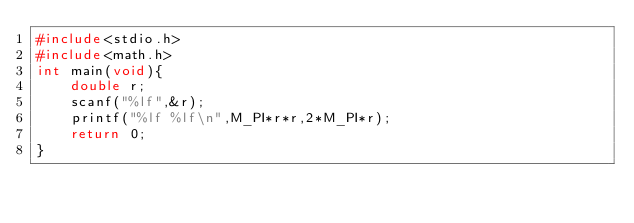<code> <loc_0><loc_0><loc_500><loc_500><_C_>#include<stdio.h>
#include<math.h>
int main(void){
    double r;
    scanf("%lf",&r);
    printf("%lf %lf\n",M_PI*r*r,2*M_PI*r);
    return 0;
}
</code> 